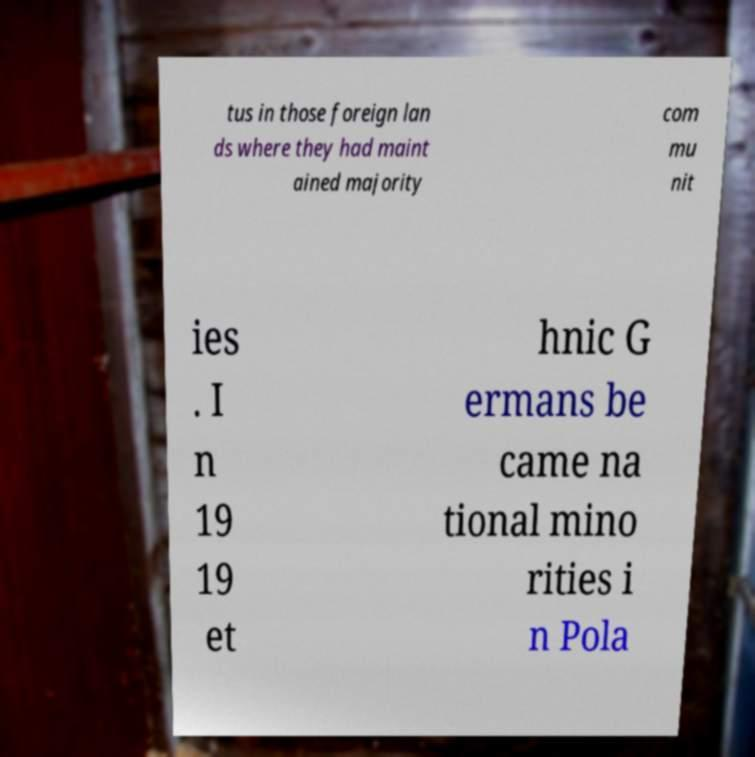Could you assist in decoding the text presented in this image and type it out clearly? tus in those foreign lan ds where they had maint ained majority com mu nit ies . I n 19 19 et hnic G ermans be came na tional mino rities i n Pola 